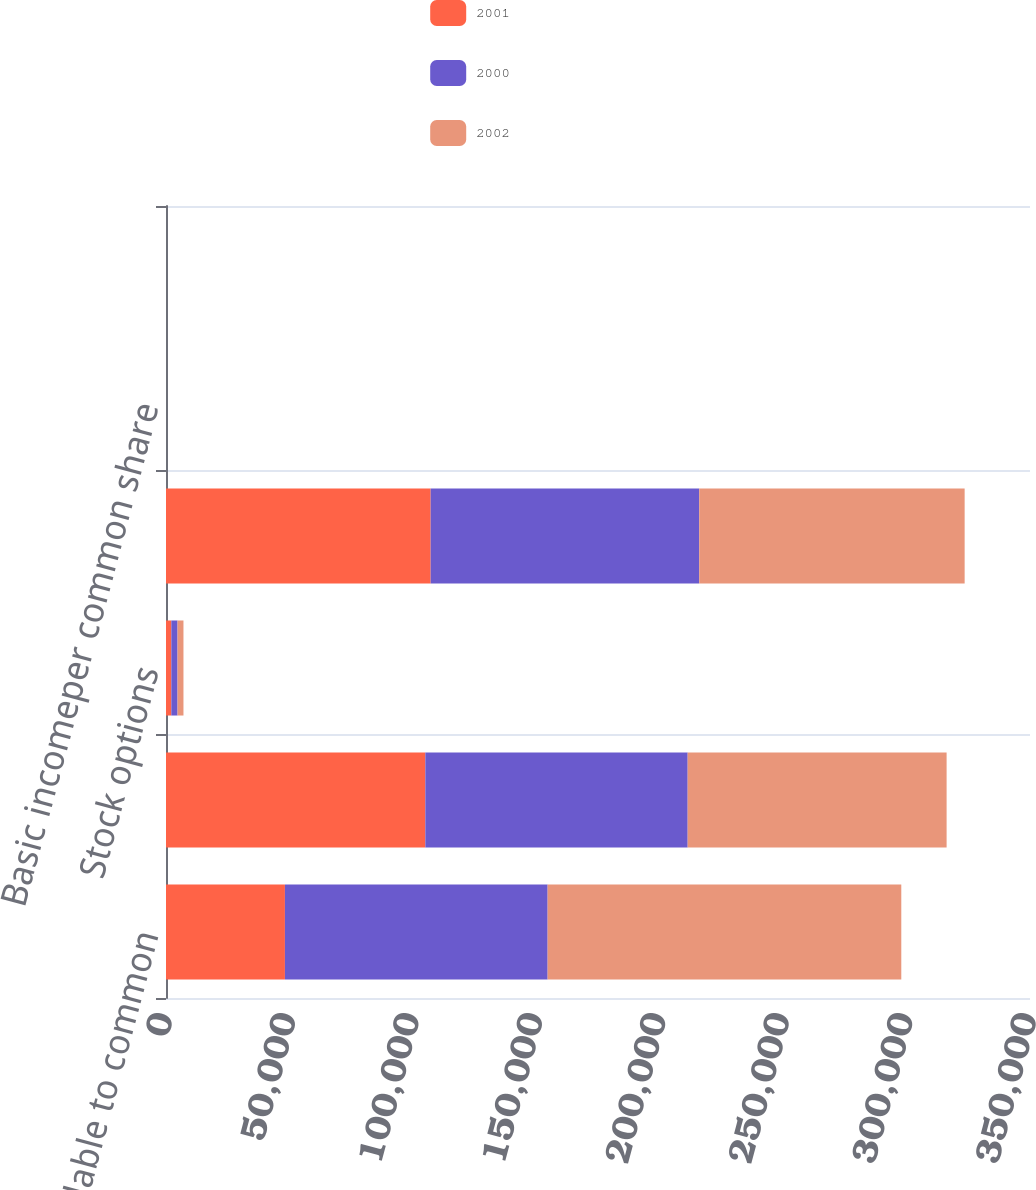Convert chart to OTSL. <chart><loc_0><loc_0><loc_500><loc_500><stacked_bar_chart><ecel><fcel>Net income available to common<fcel>Basic common shares<fcel>Stock options<fcel>Dilutive common shares<fcel>Basic incomeper common share<fcel>Diluted incomeper common share<nl><fcel>2001<fcel>48179<fcel>105053<fcel>2155<fcel>107208<fcel>0.46<fcel>0.45<nl><fcel>2000<fcel>106418<fcel>106277<fcel>2524<fcel>108801<fcel>1<fcel>0.98<nl><fcel>2002<fcel>143264<fcel>104890<fcel>2397<fcel>107518<fcel>1.37<fcel>1.33<nl></chart> 